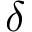Convert formula to latex. <formula><loc_0><loc_0><loc_500><loc_500>\delta</formula> 